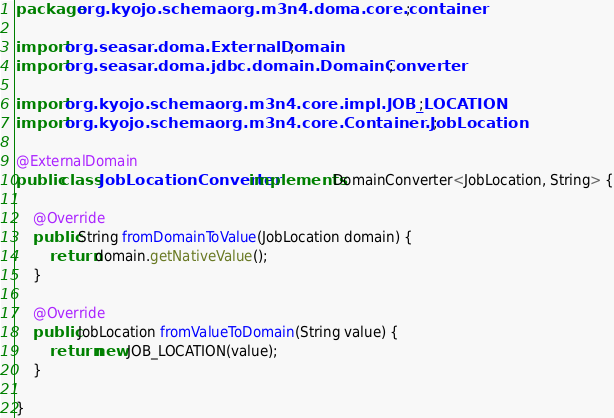<code> <loc_0><loc_0><loc_500><loc_500><_Java_>package org.kyojo.schemaorg.m3n4.doma.core.container;

import org.seasar.doma.ExternalDomain;
import org.seasar.doma.jdbc.domain.DomainConverter;

import org.kyojo.schemaorg.m3n4.core.impl.JOB_LOCATION;
import org.kyojo.schemaorg.m3n4.core.Container.JobLocation;

@ExternalDomain
public class JobLocationConverter implements DomainConverter<JobLocation, String> {

	@Override
	public String fromDomainToValue(JobLocation domain) {
		return domain.getNativeValue();
	}

	@Override
	public JobLocation fromValueToDomain(String value) {
		return new JOB_LOCATION(value);
	}

}
</code> 